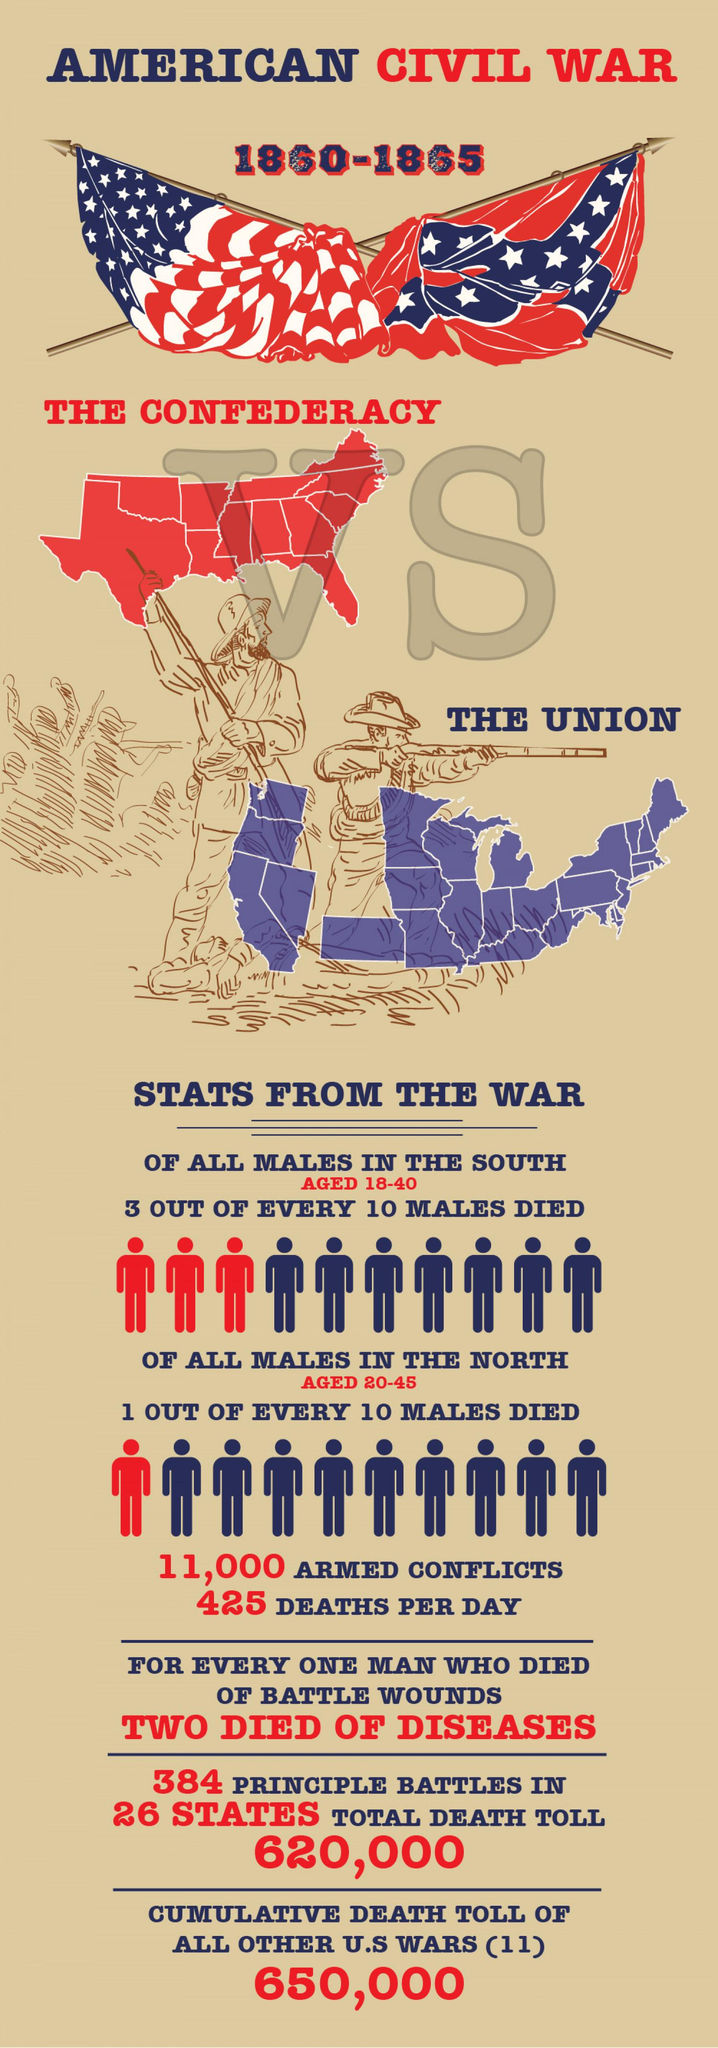Point out several critical features in this image. The Union fought against the Confederates in the Civil War. The American Civil War came to an end in 1865. Approximately 425 people died per day in the American Civil War. 